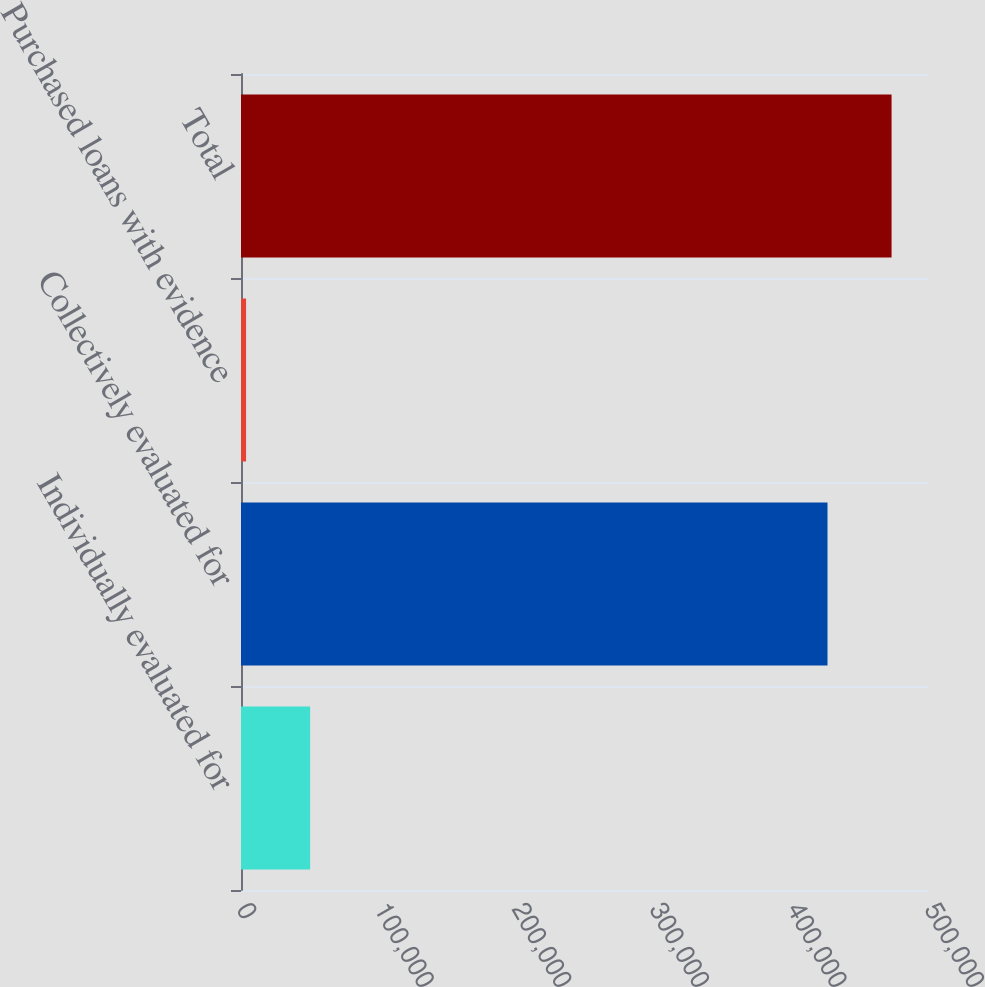<chart> <loc_0><loc_0><loc_500><loc_500><bar_chart><fcel>Individually evaluated for<fcel>Collectively evaluated for<fcel>Purchased loans with evidence<fcel>Total<nl><fcel>50237.8<fcel>426240<fcel>3685<fcel>472793<nl></chart> 